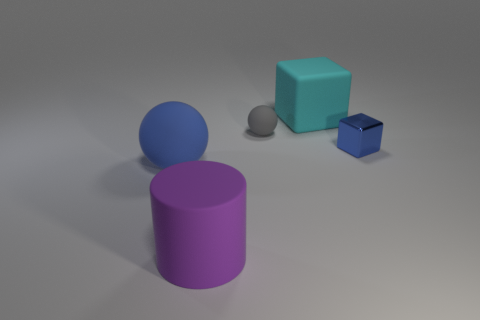What number of other objects are the same color as the large sphere?
Keep it short and to the point. 1. What number of things are large rubber objects behind the small metal block or tiny green cylinders?
Your answer should be very brief. 1. Is the color of the large sphere the same as the tiny thing to the right of the small gray matte ball?
Offer a very short reply. Yes. There is a purple matte cylinder that is left of the small thing behind the blue block; how big is it?
Provide a short and direct response. Large. How many objects are gray rubber cylinders or balls in front of the tiny blue shiny object?
Provide a succinct answer. 1. There is a thing that is right of the large cyan matte cube; is it the same shape as the cyan rubber thing?
Give a very brief answer. Yes. How many small blocks are in front of the rubber object to the left of the rubber thing in front of the blue matte thing?
Give a very brief answer. 0. Is there anything else that has the same shape as the purple rubber thing?
Ensure brevity in your answer.  No. What number of things are either blue metallic things or large purple cylinders?
Offer a terse response. 2. Do the small blue object and the small thing to the left of the small blue object have the same shape?
Offer a very short reply. No. 